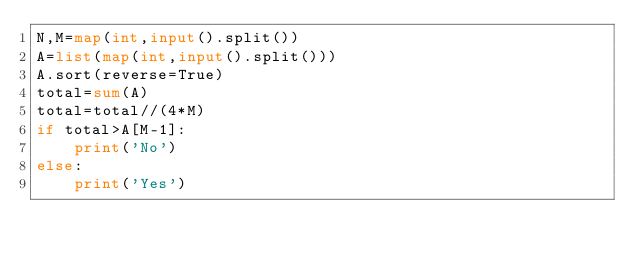Convert code to text. <code><loc_0><loc_0><loc_500><loc_500><_Python_>N,M=map(int,input().split())
A=list(map(int,input().split()))
A.sort(reverse=True)
total=sum(A)
total=total//(4*M)
if total>A[M-1]:
    print('No')
else:
    print('Yes')</code> 